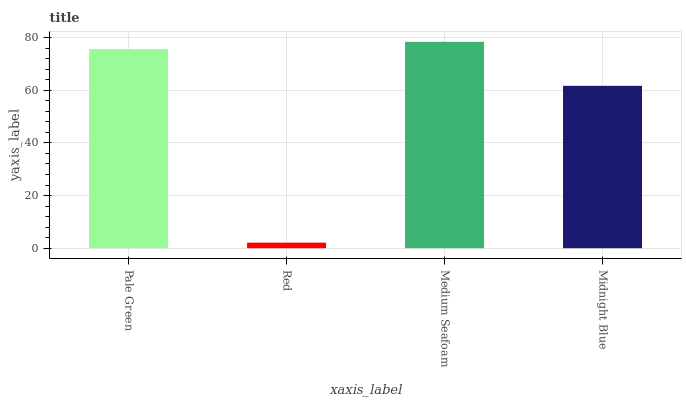Is Red the minimum?
Answer yes or no. Yes. Is Medium Seafoam the maximum?
Answer yes or no. Yes. Is Medium Seafoam the minimum?
Answer yes or no. No. Is Red the maximum?
Answer yes or no. No. Is Medium Seafoam greater than Red?
Answer yes or no. Yes. Is Red less than Medium Seafoam?
Answer yes or no. Yes. Is Red greater than Medium Seafoam?
Answer yes or no. No. Is Medium Seafoam less than Red?
Answer yes or no. No. Is Pale Green the high median?
Answer yes or no. Yes. Is Midnight Blue the low median?
Answer yes or no. Yes. Is Medium Seafoam the high median?
Answer yes or no. No. Is Red the low median?
Answer yes or no. No. 